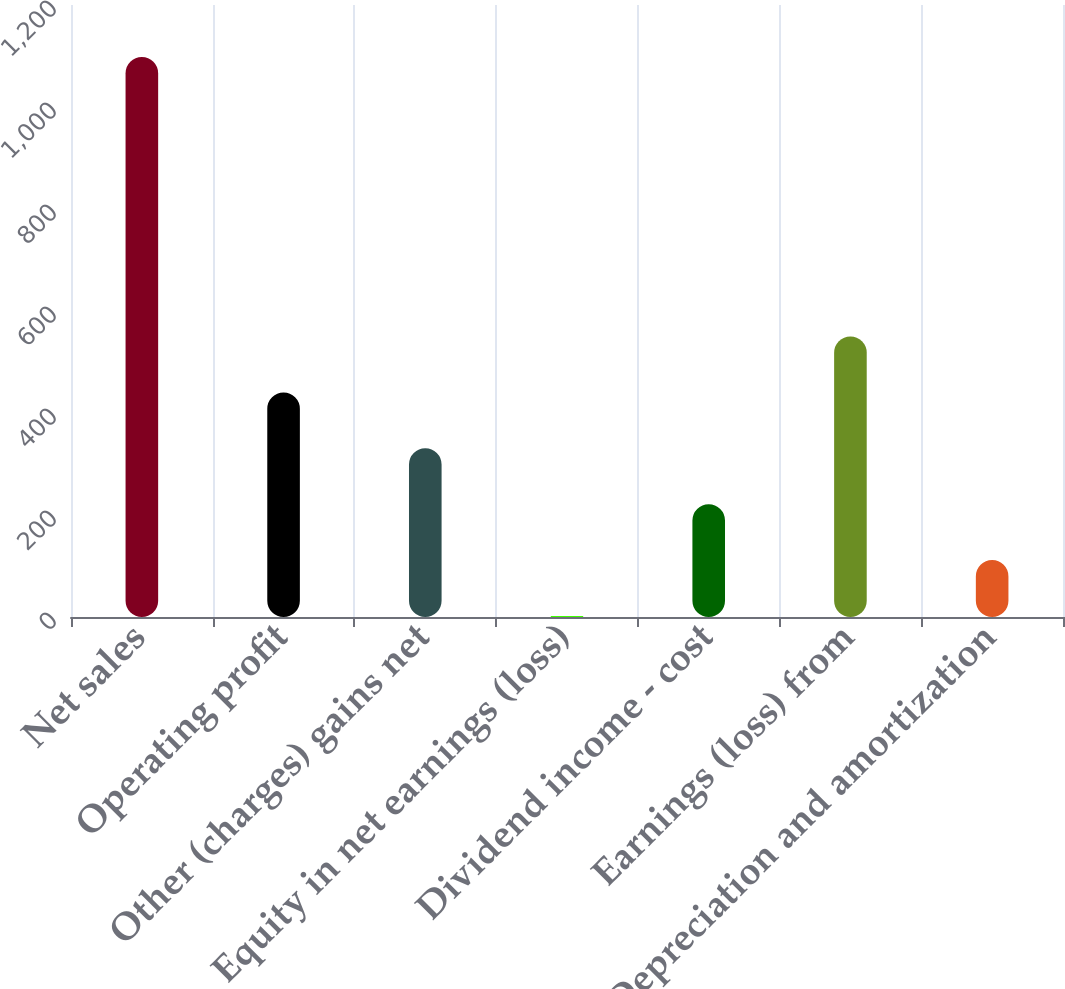Convert chart. <chart><loc_0><loc_0><loc_500><loc_500><bar_chart><fcel>Net sales<fcel>Operating profit<fcel>Other (charges) gains net<fcel>Equity in net earnings (loss)<fcel>Dividend income - cost<fcel>Earnings (loss) from<fcel>Depreciation and amortization<nl><fcel>1098<fcel>440.4<fcel>330.8<fcel>2<fcel>221.2<fcel>550<fcel>111.6<nl></chart> 